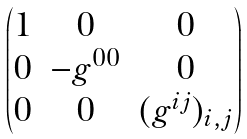Convert formula to latex. <formula><loc_0><loc_0><loc_500><loc_500>\begin{pmatrix} 1 & 0 & 0 \\ 0 & - g ^ { 0 0 } & 0 \\ 0 & 0 & ( g ^ { i j } ) _ { i , j } \end{pmatrix}</formula> 